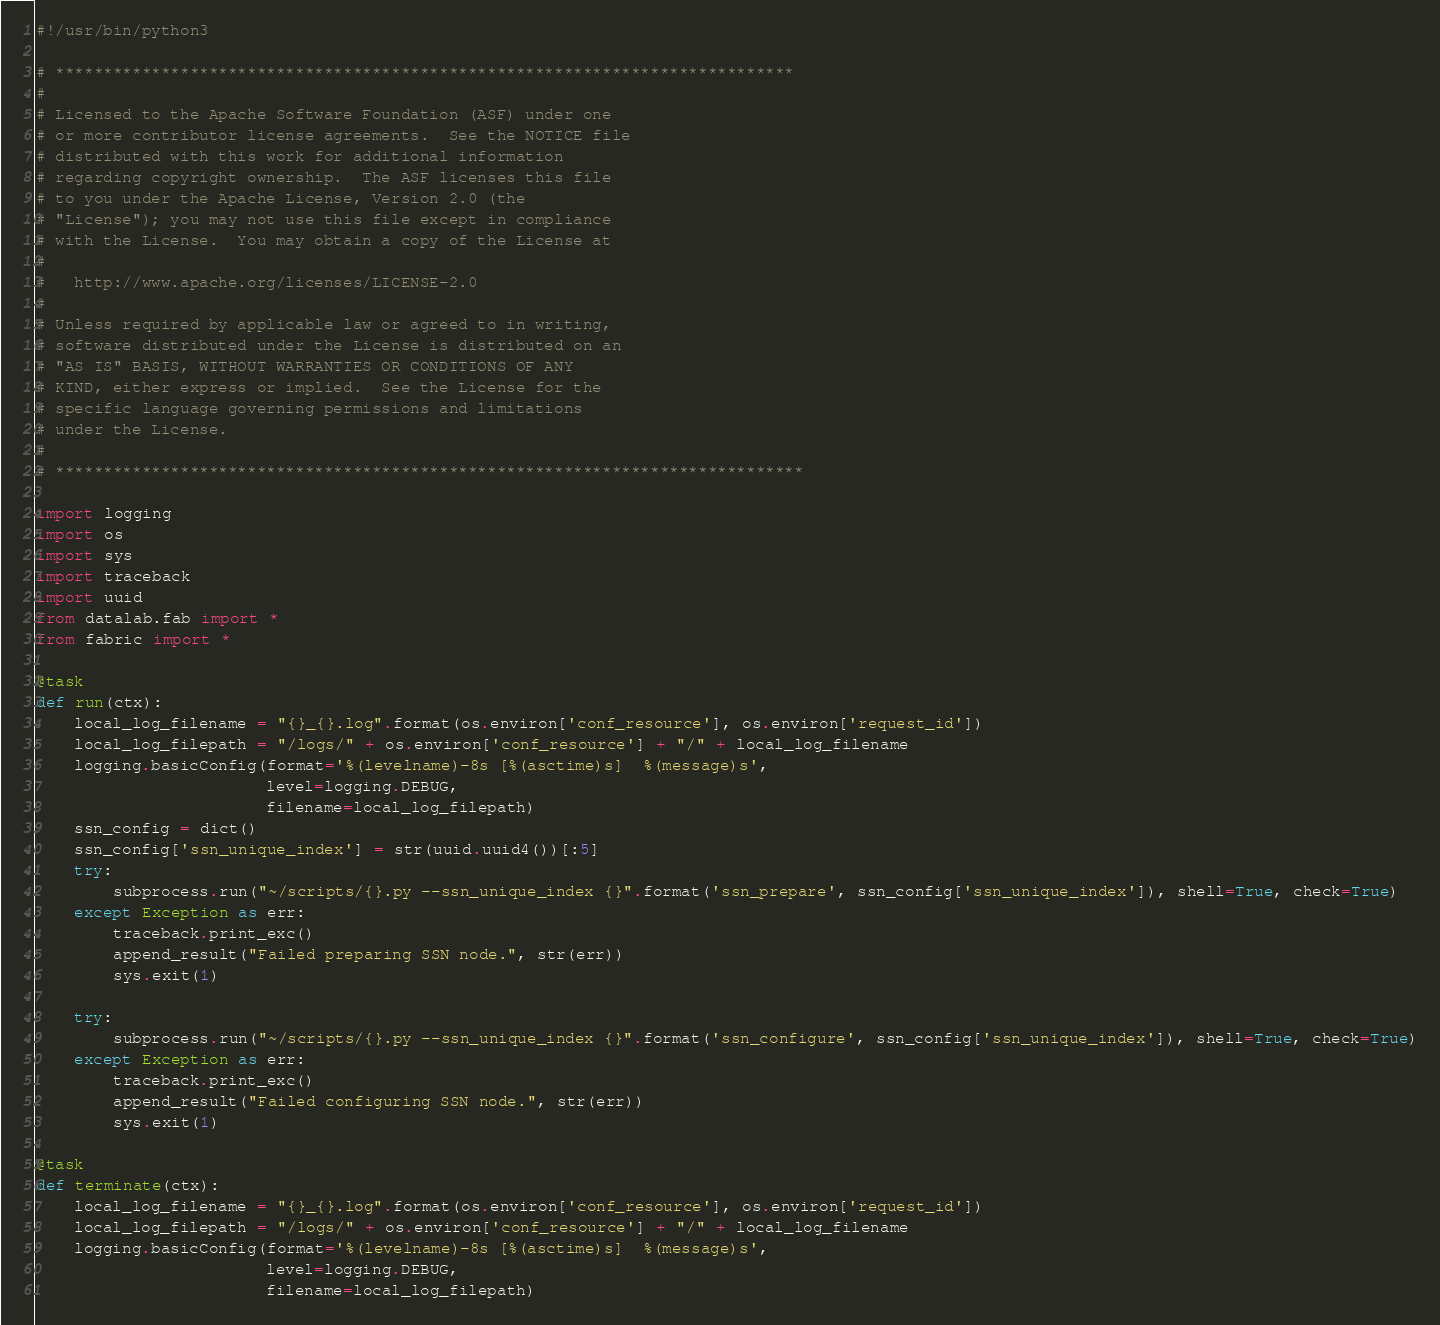<code> <loc_0><loc_0><loc_500><loc_500><_Python_>#!/usr/bin/python3

# *****************************************************************************
#
# Licensed to the Apache Software Foundation (ASF) under one
# or more contributor license agreements.  See the NOTICE file
# distributed with this work for additional information
# regarding copyright ownership.  The ASF licenses this file
# to you under the Apache License, Version 2.0 (the
# "License"); you may not use this file except in compliance
# with the License.  You may obtain a copy of the License at
#
#   http://www.apache.org/licenses/LICENSE-2.0
#
# Unless required by applicable law or agreed to in writing,
# software distributed under the License is distributed on an
# "AS IS" BASIS, WITHOUT WARRANTIES OR CONDITIONS OF ANY
# KIND, either express or implied.  See the License for the
# specific language governing permissions and limitations
# under the License.
#
# ******************************************************************************

import logging
import os
import sys
import traceback
import uuid
from datalab.fab import *
from fabric import *

@task
def run(ctx):
    local_log_filename = "{}_{}.log".format(os.environ['conf_resource'], os.environ['request_id'])
    local_log_filepath = "/logs/" + os.environ['conf_resource'] + "/" + local_log_filename
    logging.basicConfig(format='%(levelname)-8s [%(asctime)s]  %(message)s',
                        level=logging.DEBUG,
                        filename=local_log_filepath)
    ssn_config = dict()
    ssn_config['ssn_unique_index'] = str(uuid.uuid4())[:5]
    try:
        subprocess.run("~/scripts/{}.py --ssn_unique_index {}".format('ssn_prepare', ssn_config['ssn_unique_index']), shell=True, check=True)
    except Exception as err:
        traceback.print_exc()
        append_result("Failed preparing SSN node.", str(err))
        sys.exit(1)

    try:
        subprocess.run("~/scripts/{}.py --ssn_unique_index {}".format('ssn_configure', ssn_config['ssn_unique_index']), shell=True, check=True)
    except Exception as err:
        traceback.print_exc()
        append_result("Failed configuring SSN node.", str(err))
        sys.exit(1)

@task
def terminate(ctx):
    local_log_filename = "{}_{}.log".format(os.environ['conf_resource'], os.environ['request_id'])
    local_log_filepath = "/logs/" + os.environ['conf_resource'] + "/" + local_log_filename
    logging.basicConfig(format='%(levelname)-8s [%(asctime)s]  %(message)s',
                        level=logging.DEBUG,
                        filename=local_log_filepath)
</code> 